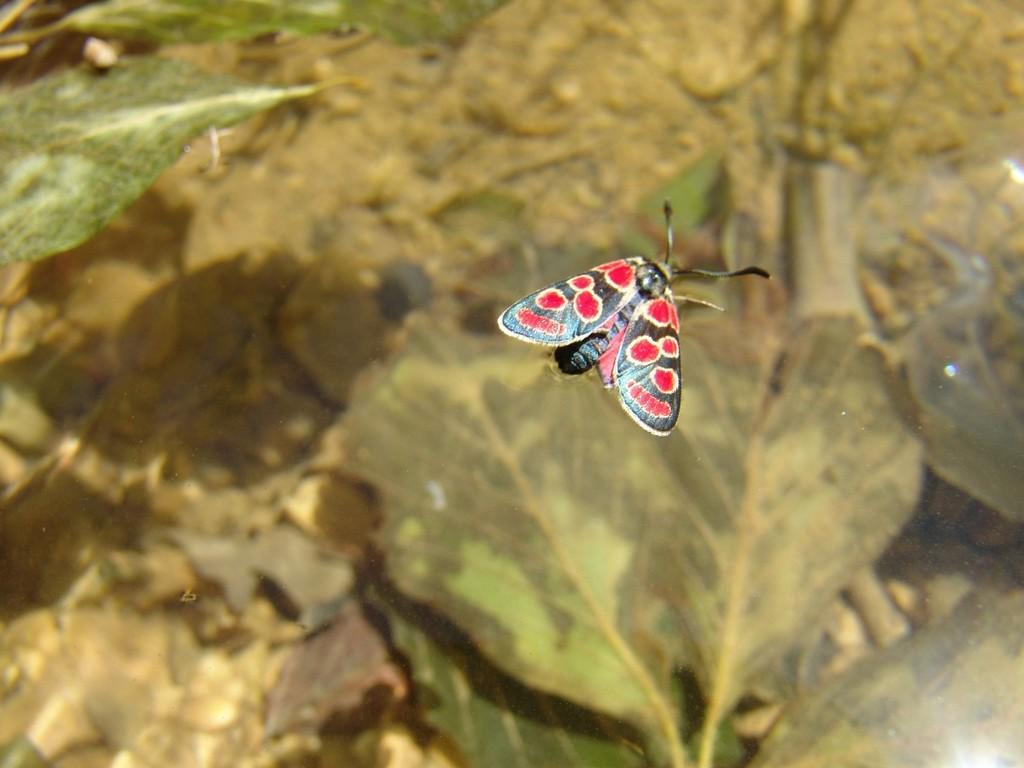What is the main subject in the front of the image? There is a butterfly in the front of the image. What can be seen in the background of the image? There are leaves in the background of the image. How many planes are visible in the image? There are no planes visible in the image; it features a butterfly and leaves. What type of screw can be seen holding the butterfly's wings together? There is no screw present in the image; it features a butterfly and leaves. 